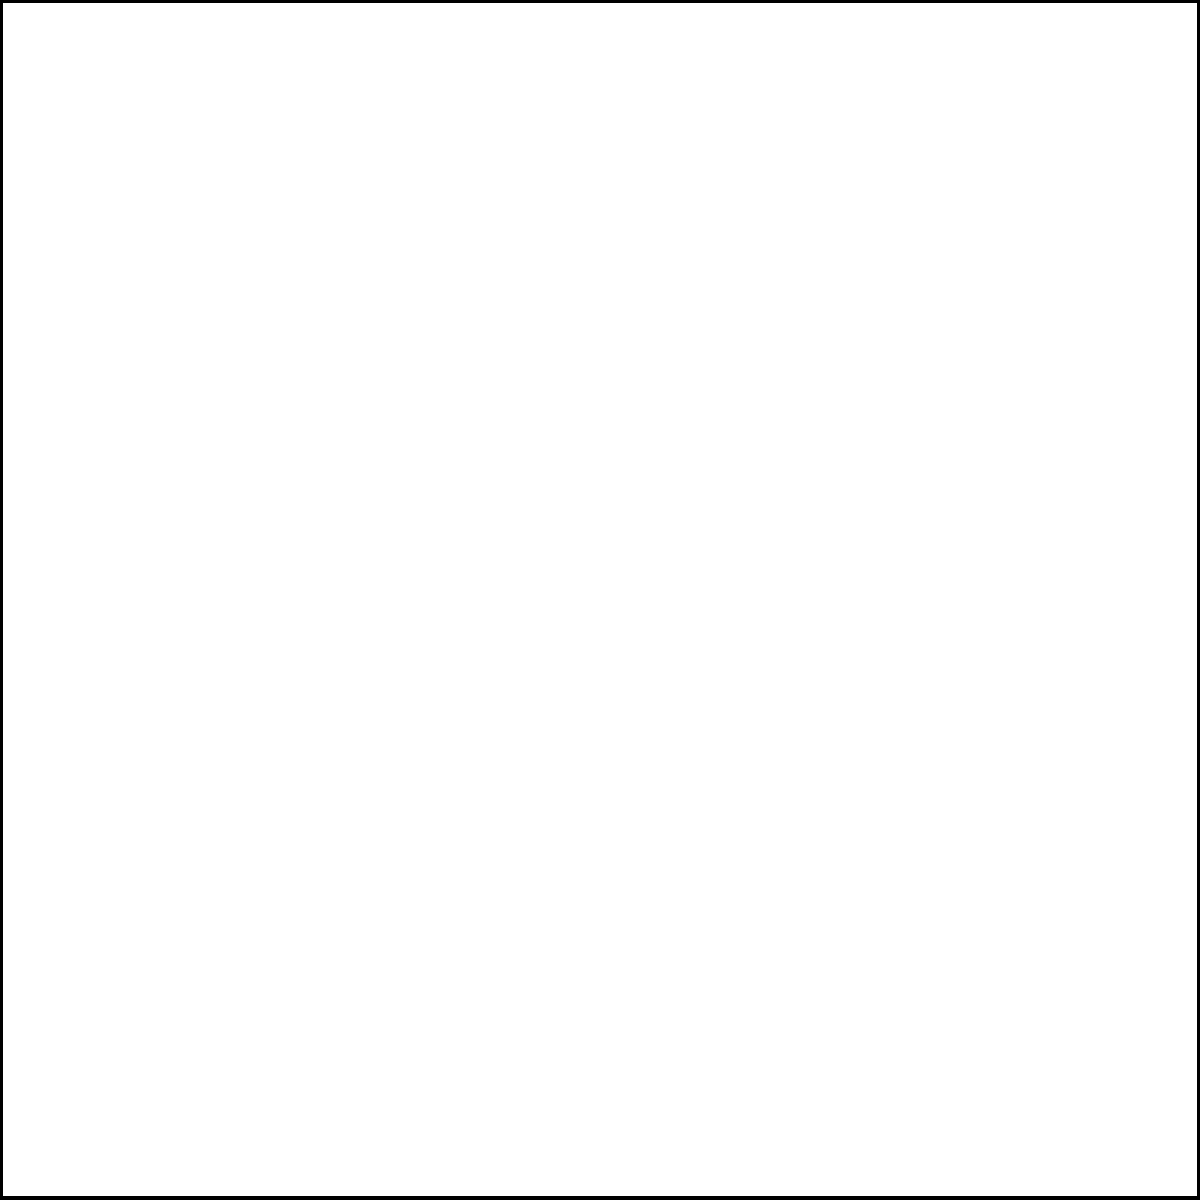In a wildlife sanctuary, a circular pond is inscribed within a square enclosure. If the side length of the square is 4 meters, what is the area of the circular pond? Consider how this efficient design maximizes space for animals while minimizing the environmental impact. Let's approach this step-by-step:

1) In a square with an inscribed circle, the diameter of the circle is equal to the side length of the square. Here, the side length is 4 meters, so the diameter of the circle is also 4 meters.

2) The radius (r) of the circle is half the diameter:
   $r = \frac{4}{2} = 2$ meters

3) The area of a circle is given by the formula:
   $A = \pi r^2$

4) Substituting our radius value:
   $A = \pi (2)^2 = 4\pi$ square meters

5) To get a numerical value, we can use $\pi \approx 3.14159$:
   $A \approx 4 * 3.14159 = 12.56636$ square meters

This design efficiently uses the square space, providing a circular habitat that maximizes the area for animals while minimizing the impact on the surrounding environment. The circular shape also promotes natural movement patterns for many species.
Answer: $4\pi$ or approximately 12.57 square meters 